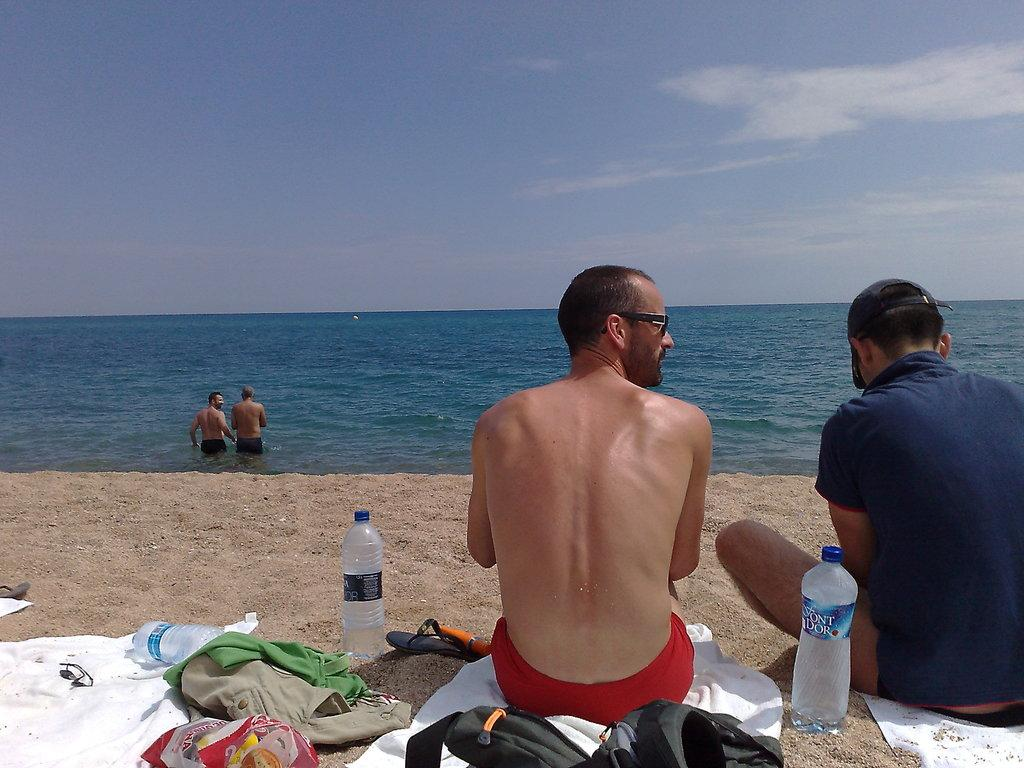What type of water body is shown in the image? The image depicts a freshwater river. What are the people in the image doing? There are persons in the water, suggesting they might be swimming or playing. What objects are on the sand near the river? There is a cloth, a bottle, and bags on the sand. How many persons are sitting on cloth in the image? Two persons are sitting on cloth in the image. What is the thumbprint on the love letter found on the sand in the image? There is no mention of a love letter or thumbprint in the image; it depicts a freshwater river with persons in the water and objects on the sand. 